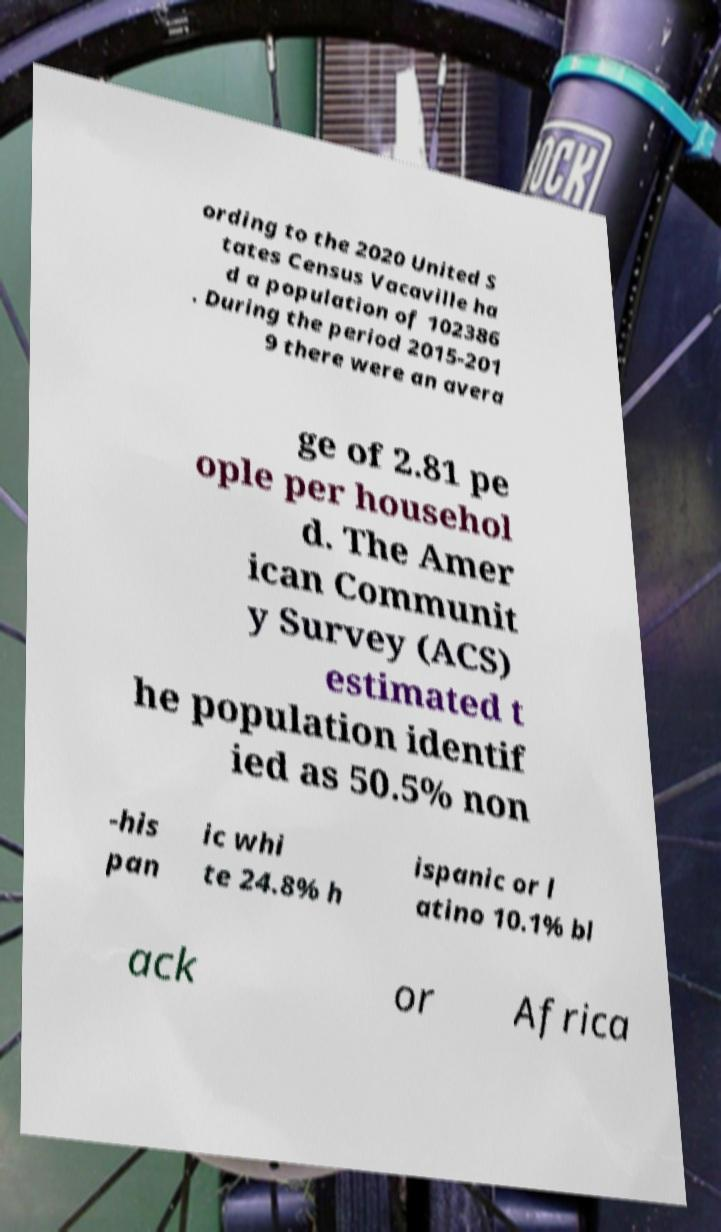Can you accurately transcribe the text from the provided image for me? ording to the 2020 United S tates Census Vacaville ha d a population of 102386 . During the period 2015-201 9 there were an avera ge of 2.81 pe ople per househol d. The Amer ican Communit y Survey (ACS) estimated t he population identif ied as 50.5% non -his pan ic whi te 24.8% h ispanic or l atino 10.1% bl ack or Africa 